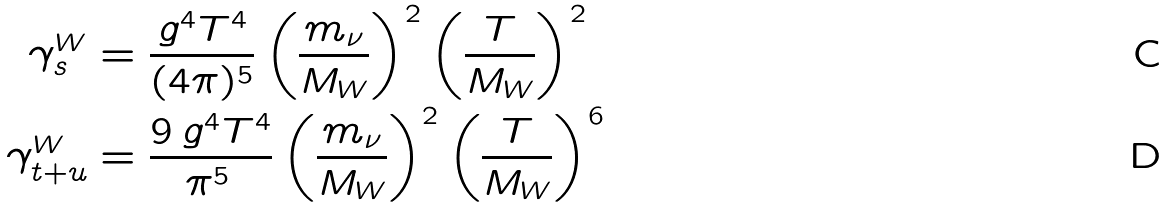Convert formula to latex. <formula><loc_0><loc_0><loc_500><loc_500>\gamma _ { s } ^ { W } & = \frac { g ^ { 4 } T ^ { 4 } } { ( 4 \pi ) ^ { 5 } } \left ( \frac { m _ { \nu } } { M _ { W } } \right ) ^ { 2 } \left ( \frac { T } { M _ { W } } \right ) ^ { 2 } \\ \gamma _ { t + u } ^ { W } & = \frac { 9 \, g ^ { 4 } T ^ { 4 } } { \pi ^ { 5 } \, } \left ( \frac { m _ { \nu } } { M _ { W } } \right ) ^ { 2 } \left ( \frac { T } { M _ { W } } \right ) ^ { 6 }</formula> 